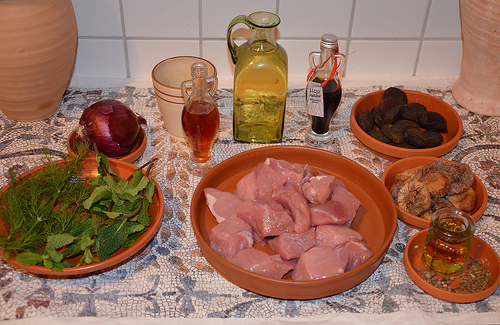<image>
Is the meat under the bottle? No. The meat is not positioned under the bottle. The vertical relationship between these objects is different. Is the meat under the bowl? No. The meat is not positioned under the bowl. The vertical relationship between these objects is different. 